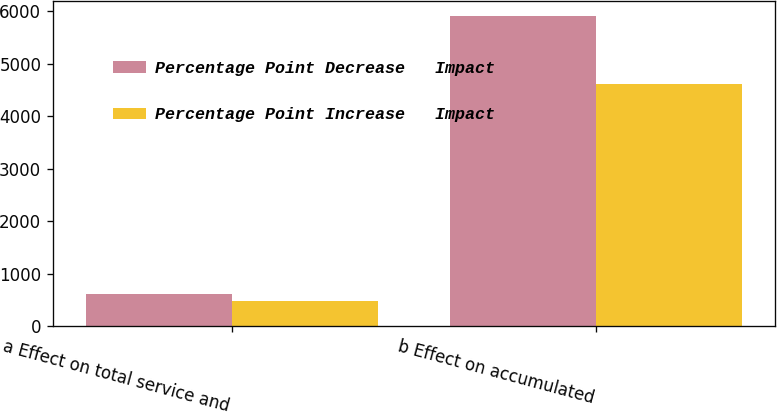<chart> <loc_0><loc_0><loc_500><loc_500><stacked_bar_chart><ecel><fcel>a Effect on total service and<fcel>b Effect on accumulated<nl><fcel>Percentage Point Decrease   Impact<fcel>617<fcel>5905<nl><fcel>Percentage Point Increase   Impact<fcel>478<fcel>4611<nl></chart> 